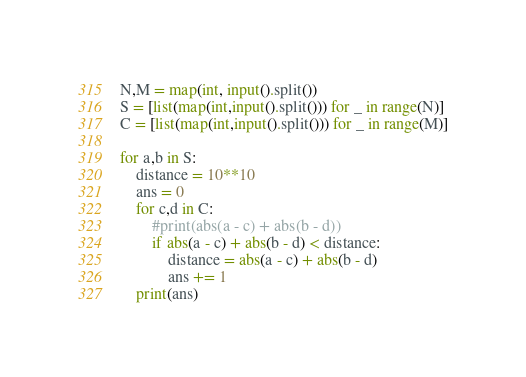<code> <loc_0><loc_0><loc_500><loc_500><_Python_>N,M = map(int, input().split())
S = [list(map(int,input().split())) for _ in range(N)]
C = [list(map(int,input().split())) for _ in range(M)]

for a,b in S:
    distance = 10**10
    ans = 0
    for c,d in C:
        #print(abs(a - c) + abs(b - d))
        if abs(a - c) + abs(b - d) < distance:
            distance = abs(a - c) + abs(b - d)
            ans += 1
    print(ans)


</code> 